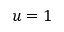<formula> <loc_0><loc_0><loc_500><loc_500>u = 1</formula> 